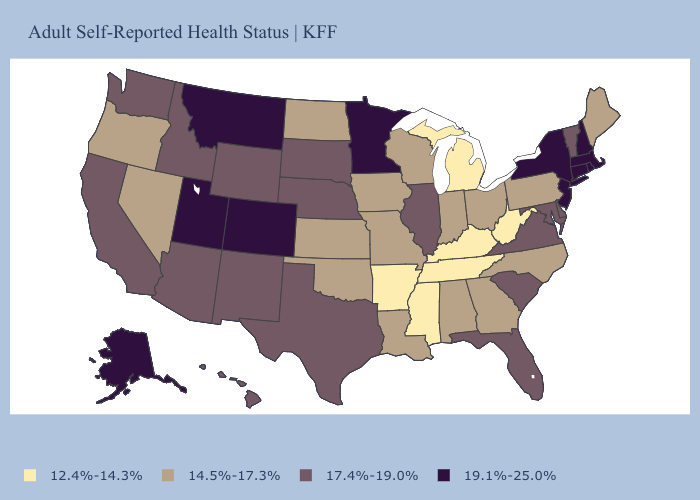Which states hav the highest value in the Northeast?
Short answer required. Connecticut, Massachusetts, New Hampshire, New Jersey, New York, Rhode Island. Does Idaho have the highest value in the USA?
Write a very short answer. No. What is the value of New Jersey?
Quick response, please. 19.1%-25.0%. What is the value of Hawaii?
Keep it brief. 17.4%-19.0%. Name the states that have a value in the range 14.5%-17.3%?
Quick response, please. Alabama, Georgia, Indiana, Iowa, Kansas, Louisiana, Maine, Missouri, Nevada, North Carolina, North Dakota, Ohio, Oklahoma, Oregon, Pennsylvania, Wisconsin. Name the states that have a value in the range 12.4%-14.3%?
Keep it brief. Arkansas, Kentucky, Michigan, Mississippi, Tennessee, West Virginia. Does Georgia have the lowest value in the USA?
Answer briefly. No. Among the states that border Oklahoma , does Colorado have the highest value?
Answer briefly. Yes. Name the states that have a value in the range 12.4%-14.3%?
Write a very short answer. Arkansas, Kentucky, Michigan, Mississippi, Tennessee, West Virginia. Which states have the lowest value in the Northeast?
Be succinct. Maine, Pennsylvania. Does Pennsylvania have the highest value in the Northeast?
Concise answer only. No. Among the states that border New Jersey , does Pennsylvania have the highest value?
Short answer required. No. Does South Carolina have the highest value in the South?
Concise answer only. Yes. Which states have the highest value in the USA?
Quick response, please. Alaska, Colorado, Connecticut, Massachusetts, Minnesota, Montana, New Hampshire, New Jersey, New York, Rhode Island, Utah. How many symbols are there in the legend?
Quick response, please. 4. 